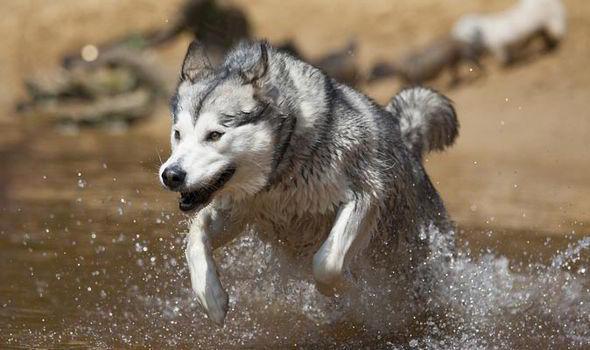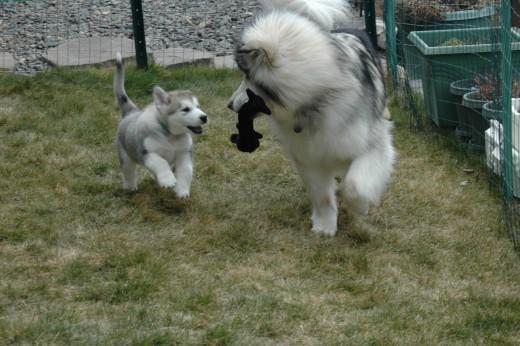The first image is the image on the left, the second image is the image on the right. For the images displayed, is the sentence "The husky is holding something in its mouth." factually correct? Answer yes or no. Yes. The first image is the image on the left, the second image is the image on the right. Given the left and right images, does the statement "There are two dogs on grass." hold true? Answer yes or no. Yes. 